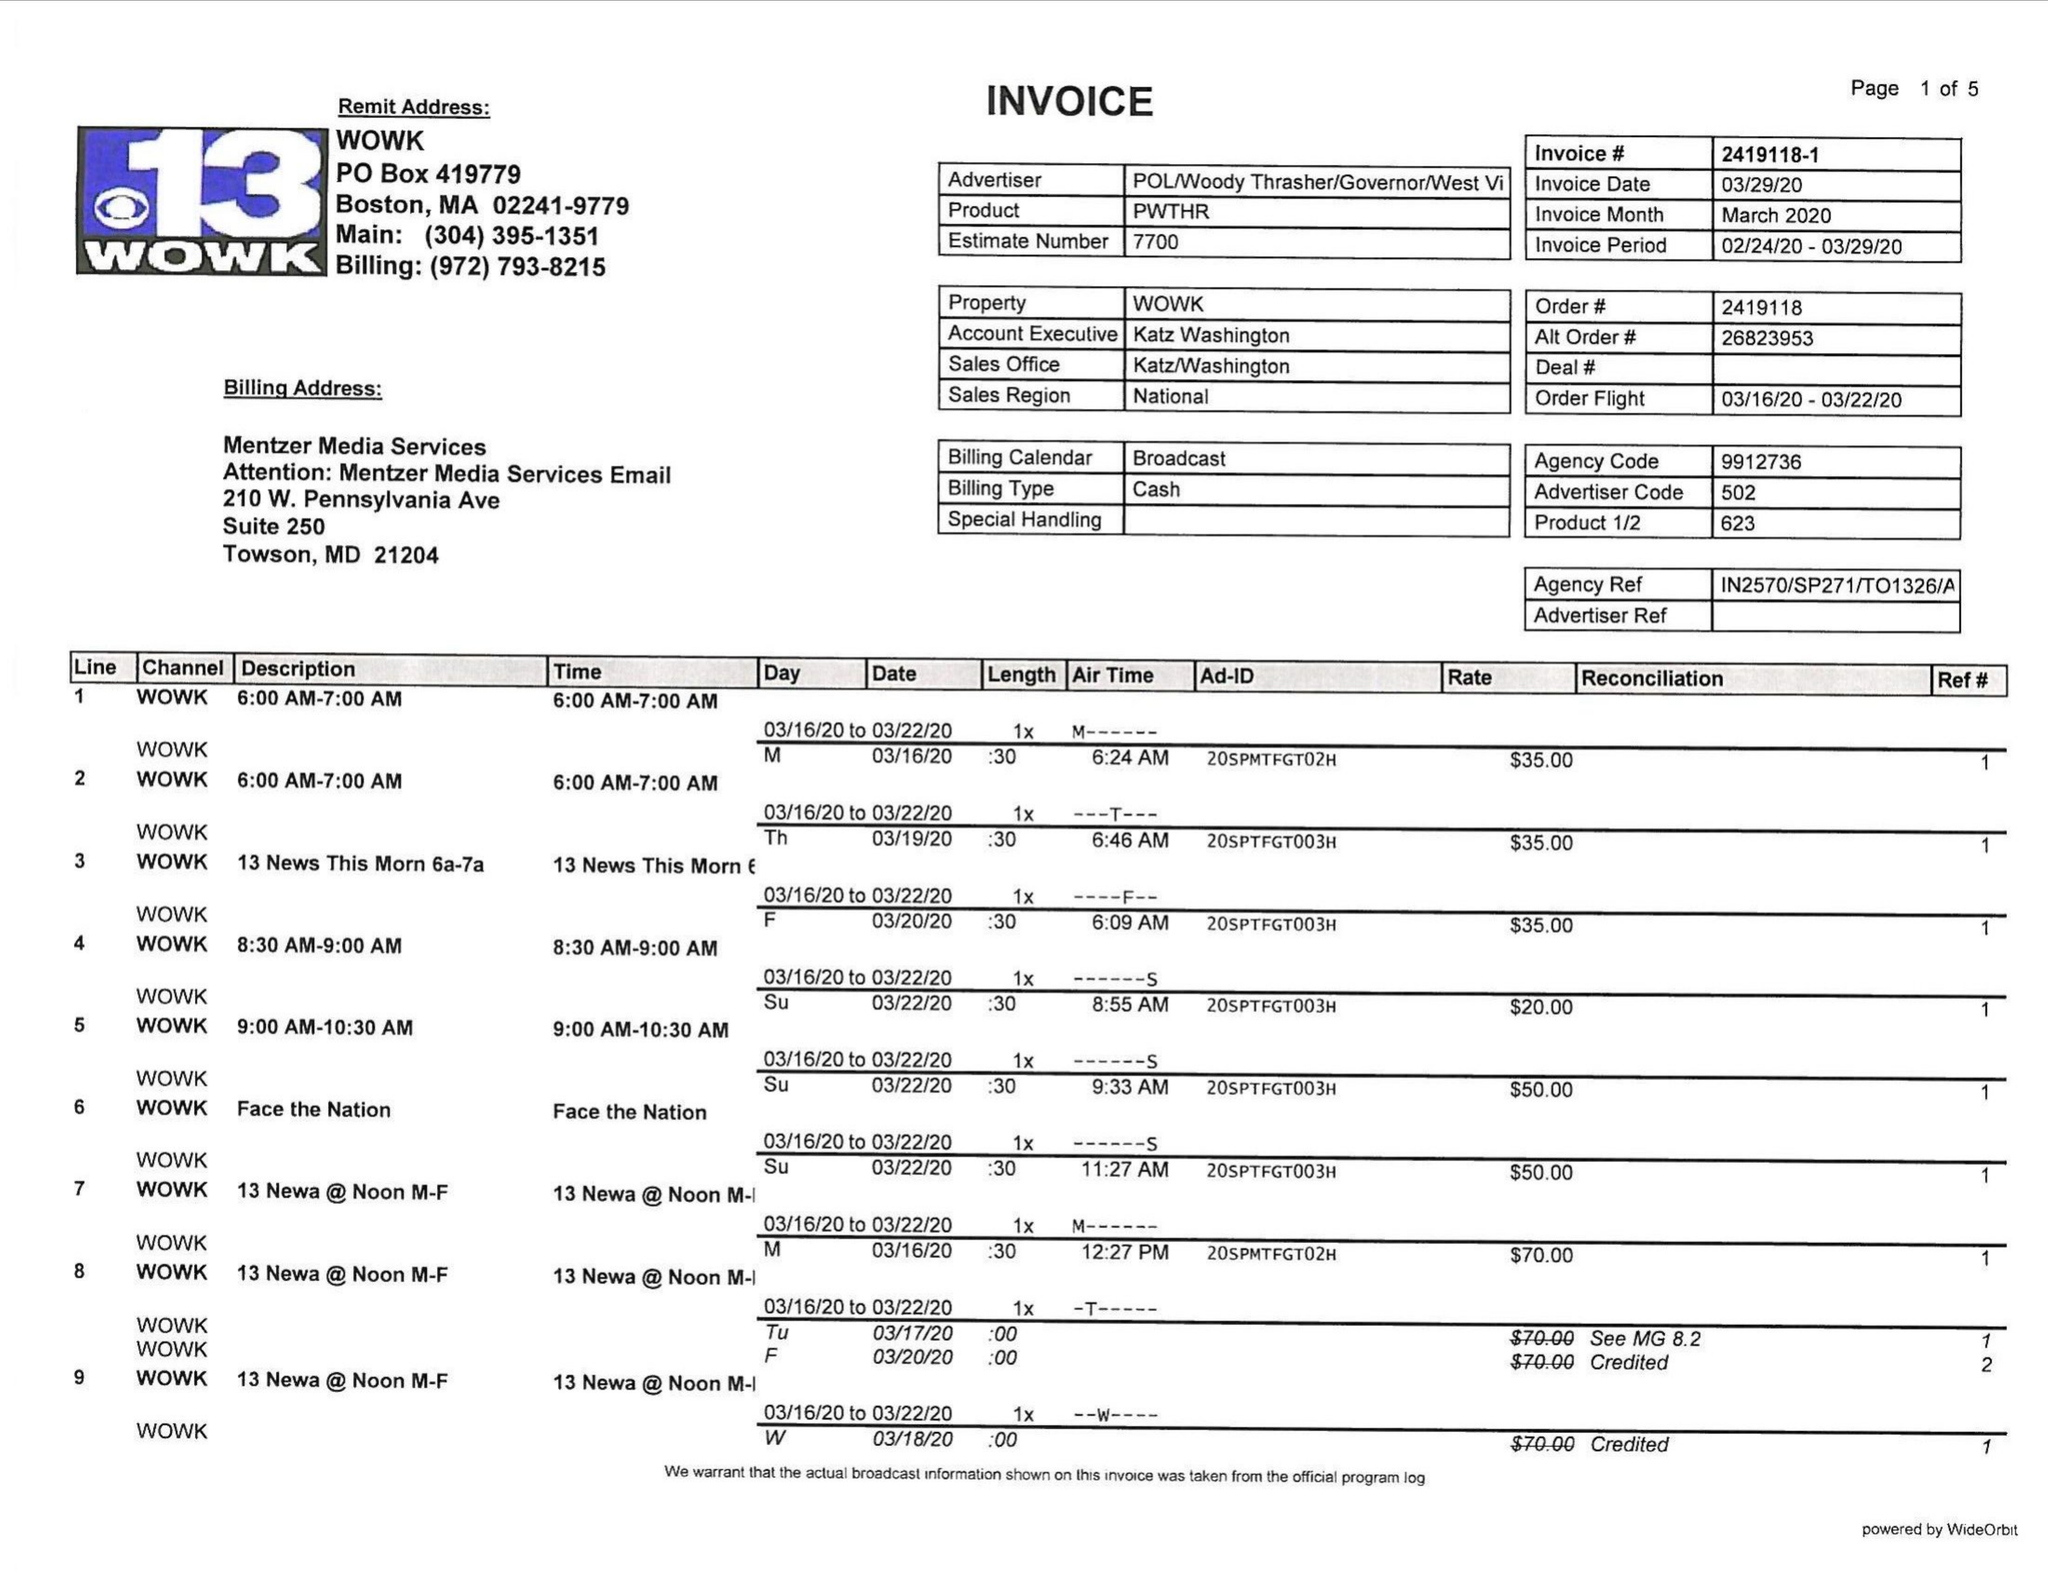What is the value for the gross_amount?
Answer the question using a single word or phrase. 4765.00 